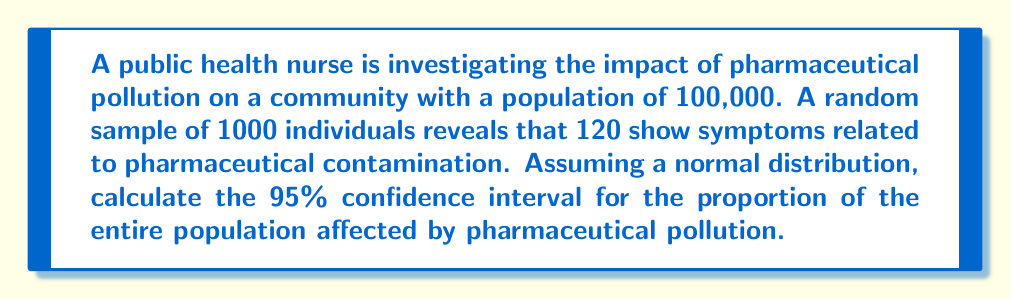Give your solution to this math problem. Let's approach this step-by-step:

1) First, we need to calculate the sample proportion:
   $\hat{p} = \frac{120}{1000} = 0.12$ or 12%

2) For a 95% confidence interval, we use a z-score of 1.96.

3) The formula for the confidence interval is:

   $$\hat{p} \pm z \sqrt{\frac{\hat{p}(1-\hat{p})}{n}}$$

   where $\hat{p}$ is the sample proportion, $z$ is the z-score, and $n$ is the sample size.

4) Let's calculate the margin of error:

   $$\text{Margin of Error} = 1.96 \sqrt{\frac{0.12(1-0.12)}{1000}}$$
   $$= 1.96 \sqrt{\frac{0.1056}{1000}} = 1.96 \sqrt{0.0001056} = 1.96(0.0103) = 0.02019$$

5) Now we can calculate the confidence interval:
   
   Lower bound: $0.12 - 0.02019 = 0.09981$
   Upper bound: $0.12 + 0.02019 = 0.14019$

6) Converting to percentages:
   
   Lower bound: 9.981%
   Upper bound: 14.019%

7) To estimate the number of people affected in the total population:

   Lower: $100,000 \times 0.09981 = 9,981$
   Upper: $100,000 \times 0.14019 = 14,019$
Answer: 95% CI: 9,981 to 14,019 people (9.981% to 14.019% of the population) 